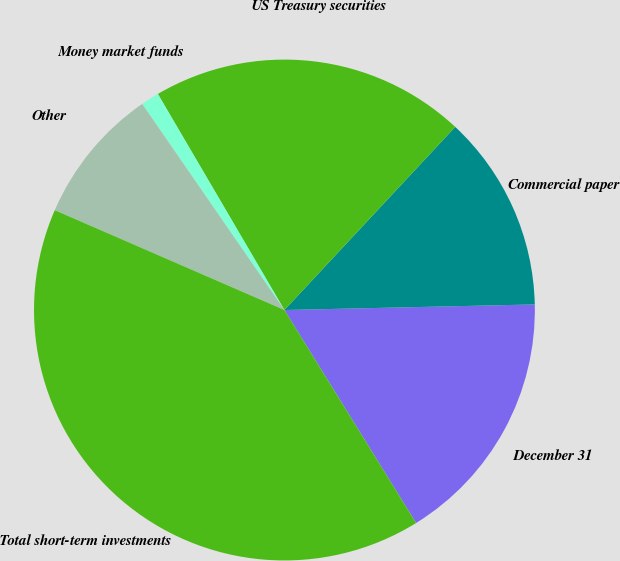<chart> <loc_0><loc_0><loc_500><loc_500><pie_chart><fcel>December 31<fcel>Commercial paper<fcel>US Treasury securities<fcel>Money market funds<fcel>Other<fcel>Total short-term investments<nl><fcel>16.54%<fcel>12.7%<fcel>20.38%<fcel>1.18%<fcel>8.86%<fcel>40.34%<nl></chart> 